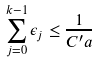Convert formula to latex. <formula><loc_0><loc_0><loc_500><loc_500>\sum _ { j = 0 } ^ { k - 1 } \epsilon _ { j } \leq \frac { 1 } { C ^ { \prime } a }</formula> 